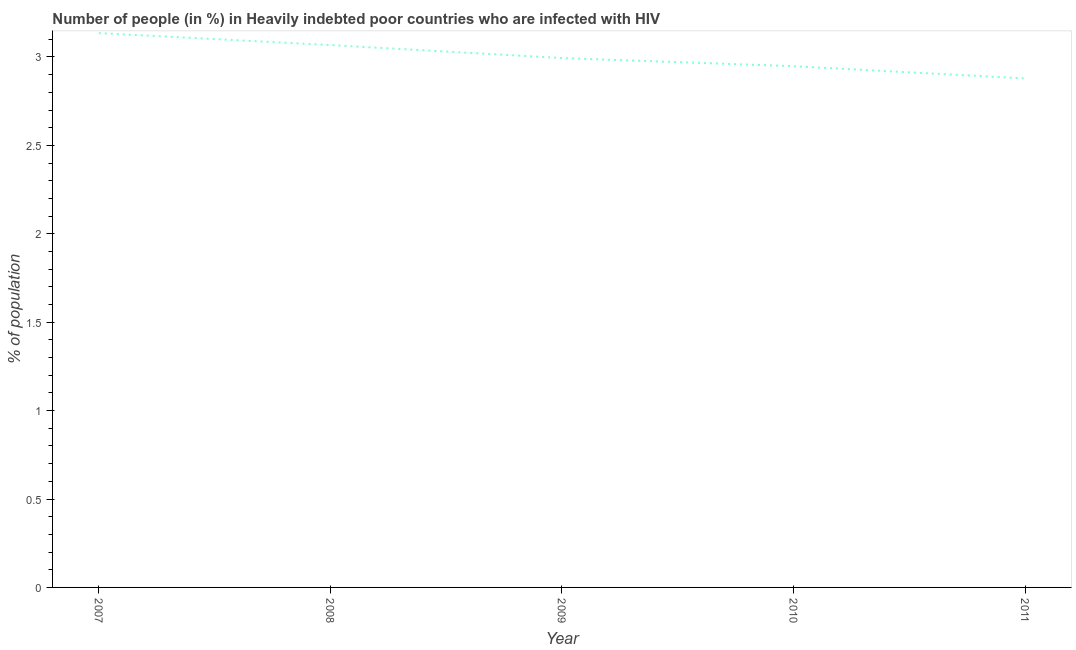What is the number of people infected with hiv in 2008?
Make the answer very short. 3.07. Across all years, what is the maximum number of people infected with hiv?
Your answer should be compact. 3.14. Across all years, what is the minimum number of people infected with hiv?
Provide a succinct answer. 2.88. In which year was the number of people infected with hiv maximum?
Give a very brief answer. 2007. What is the sum of the number of people infected with hiv?
Your answer should be compact. 15.02. What is the difference between the number of people infected with hiv in 2008 and 2010?
Your response must be concise. 0.12. What is the average number of people infected with hiv per year?
Offer a terse response. 3. What is the median number of people infected with hiv?
Give a very brief answer. 2.99. What is the ratio of the number of people infected with hiv in 2007 to that in 2010?
Your answer should be very brief. 1.06. Is the number of people infected with hiv in 2007 less than that in 2010?
Offer a very short reply. No. Is the difference between the number of people infected with hiv in 2009 and 2011 greater than the difference between any two years?
Ensure brevity in your answer.  No. What is the difference between the highest and the second highest number of people infected with hiv?
Your answer should be compact. 0.07. What is the difference between the highest and the lowest number of people infected with hiv?
Provide a succinct answer. 0.26. In how many years, is the number of people infected with hiv greater than the average number of people infected with hiv taken over all years?
Provide a short and direct response. 2. Does the number of people infected with hiv monotonically increase over the years?
Your response must be concise. No. Does the graph contain any zero values?
Offer a very short reply. No. Does the graph contain grids?
Keep it short and to the point. No. What is the title of the graph?
Your response must be concise. Number of people (in %) in Heavily indebted poor countries who are infected with HIV. What is the label or title of the X-axis?
Keep it short and to the point. Year. What is the label or title of the Y-axis?
Keep it short and to the point. % of population. What is the % of population in 2007?
Make the answer very short. 3.14. What is the % of population of 2008?
Keep it short and to the point. 3.07. What is the % of population of 2009?
Your answer should be very brief. 2.99. What is the % of population in 2010?
Keep it short and to the point. 2.95. What is the % of population of 2011?
Offer a very short reply. 2.88. What is the difference between the % of population in 2007 and 2008?
Provide a short and direct response. 0.07. What is the difference between the % of population in 2007 and 2009?
Your response must be concise. 0.14. What is the difference between the % of population in 2007 and 2010?
Ensure brevity in your answer.  0.19. What is the difference between the % of population in 2007 and 2011?
Give a very brief answer. 0.26. What is the difference between the % of population in 2008 and 2009?
Provide a succinct answer. 0.07. What is the difference between the % of population in 2008 and 2010?
Your answer should be very brief. 0.12. What is the difference between the % of population in 2008 and 2011?
Offer a terse response. 0.19. What is the difference between the % of population in 2009 and 2010?
Ensure brevity in your answer.  0.05. What is the difference between the % of population in 2009 and 2011?
Your answer should be compact. 0.12. What is the difference between the % of population in 2010 and 2011?
Provide a short and direct response. 0.07. What is the ratio of the % of population in 2007 to that in 2009?
Keep it short and to the point. 1.05. What is the ratio of the % of population in 2007 to that in 2010?
Offer a terse response. 1.06. What is the ratio of the % of population in 2007 to that in 2011?
Offer a very short reply. 1.09. What is the ratio of the % of population in 2008 to that in 2009?
Make the answer very short. 1.02. What is the ratio of the % of population in 2008 to that in 2010?
Provide a succinct answer. 1.04. What is the ratio of the % of population in 2008 to that in 2011?
Ensure brevity in your answer.  1.06. What is the ratio of the % of population in 2009 to that in 2010?
Your answer should be very brief. 1.02. What is the ratio of the % of population in 2009 to that in 2011?
Make the answer very short. 1.04. 